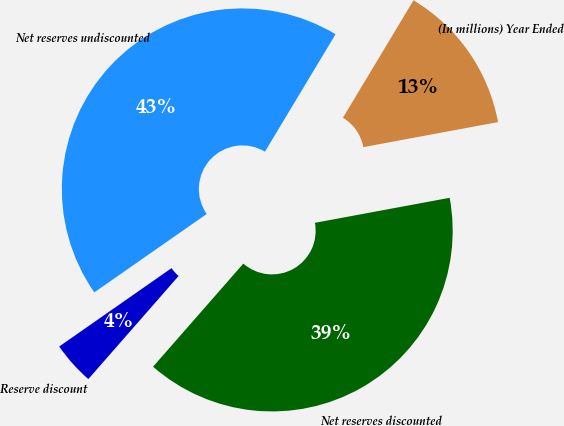Convert chart. <chart><loc_0><loc_0><loc_500><loc_500><pie_chart><fcel>(In millions) Year Ended<fcel>Net reserves discounted<fcel>Reserve discount<fcel>Net reserves undiscounted<nl><fcel>13.46%<fcel>39.37%<fcel>3.86%<fcel>43.31%<nl></chart> 